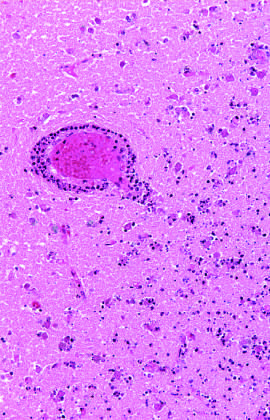when does an area of infarction show the presence of macrophages and surrounding reactive gliosis?
Answer the question using a single word or phrase. By day 10 